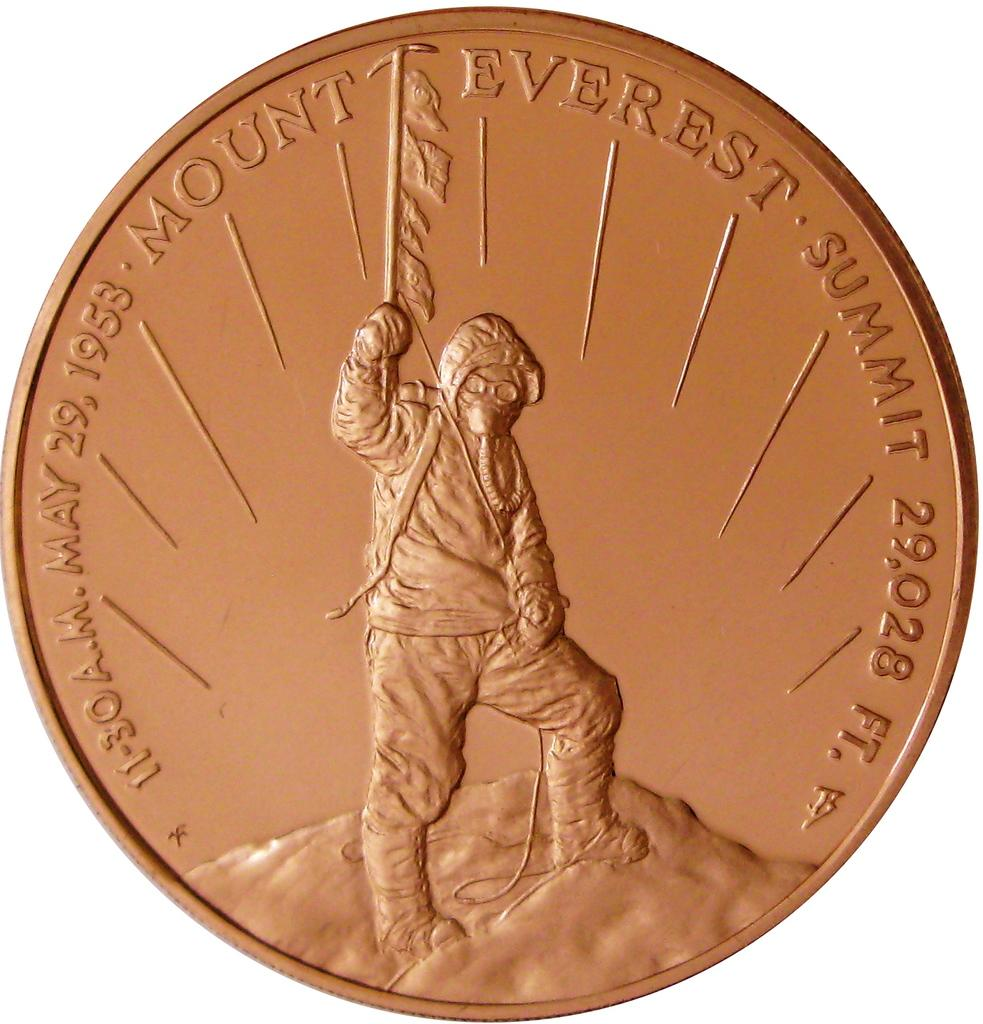<image>
Present a compact description of the photo's key features. A commemorative bronze coin for Mount Everest witha person holding a flag. 